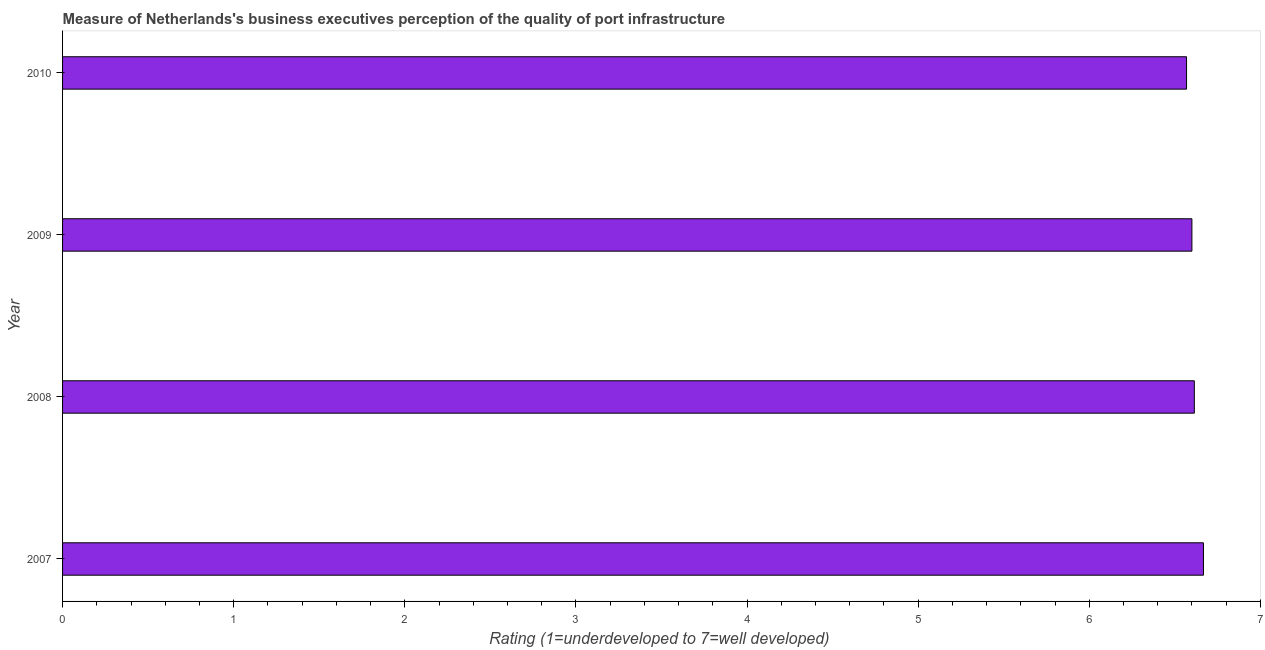Does the graph contain grids?
Ensure brevity in your answer.  No. What is the title of the graph?
Provide a short and direct response. Measure of Netherlands's business executives perception of the quality of port infrastructure. What is the label or title of the X-axis?
Offer a terse response. Rating (1=underdeveloped to 7=well developed) . What is the rating measuring quality of port infrastructure in 2007?
Make the answer very short. 6.67. Across all years, what is the maximum rating measuring quality of port infrastructure?
Provide a short and direct response. 6.67. Across all years, what is the minimum rating measuring quality of port infrastructure?
Your answer should be compact. 6.57. In which year was the rating measuring quality of port infrastructure maximum?
Ensure brevity in your answer.  2007. What is the sum of the rating measuring quality of port infrastructure?
Provide a succinct answer. 26.45. What is the difference between the rating measuring quality of port infrastructure in 2007 and 2010?
Give a very brief answer. 0.1. What is the average rating measuring quality of port infrastructure per year?
Make the answer very short. 6.61. What is the median rating measuring quality of port infrastructure?
Your answer should be compact. 6.61. In how many years, is the rating measuring quality of port infrastructure greater than 4 ?
Offer a terse response. 4. Do a majority of the years between 2009 and 2010 (inclusive) have rating measuring quality of port infrastructure greater than 0.4 ?
Make the answer very short. Yes. What is the ratio of the rating measuring quality of port infrastructure in 2009 to that in 2010?
Ensure brevity in your answer.  1. Is the difference between the rating measuring quality of port infrastructure in 2007 and 2009 greater than the difference between any two years?
Your response must be concise. No. What is the difference between the highest and the second highest rating measuring quality of port infrastructure?
Give a very brief answer. 0.05. Is the sum of the rating measuring quality of port infrastructure in 2008 and 2009 greater than the maximum rating measuring quality of port infrastructure across all years?
Your response must be concise. Yes. How many bars are there?
Keep it short and to the point. 4. Are all the bars in the graph horizontal?
Make the answer very short. Yes. What is the difference between two consecutive major ticks on the X-axis?
Make the answer very short. 1. What is the Rating (1=underdeveloped to 7=well developed)  in 2007?
Make the answer very short. 6.67. What is the Rating (1=underdeveloped to 7=well developed)  in 2008?
Your answer should be very brief. 6.61. What is the Rating (1=underdeveloped to 7=well developed)  in 2009?
Your answer should be compact. 6.6. What is the Rating (1=underdeveloped to 7=well developed)  in 2010?
Provide a succinct answer. 6.57. What is the difference between the Rating (1=underdeveloped to 7=well developed)  in 2007 and 2008?
Provide a short and direct response. 0.05. What is the difference between the Rating (1=underdeveloped to 7=well developed)  in 2007 and 2009?
Offer a terse response. 0.07. What is the difference between the Rating (1=underdeveloped to 7=well developed)  in 2007 and 2010?
Your answer should be very brief. 0.1. What is the difference between the Rating (1=underdeveloped to 7=well developed)  in 2008 and 2009?
Provide a short and direct response. 0.01. What is the difference between the Rating (1=underdeveloped to 7=well developed)  in 2008 and 2010?
Your response must be concise. 0.05. What is the difference between the Rating (1=underdeveloped to 7=well developed)  in 2009 and 2010?
Your answer should be very brief. 0.03. What is the ratio of the Rating (1=underdeveloped to 7=well developed)  in 2007 to that in 2010?
Ensure brevity in your answer.  1.01. What is the ratio of the Rating (1=underdeveloped to 7=well developed)  in 2009 to that in 2010?
Your answer should be very brief. 1. 